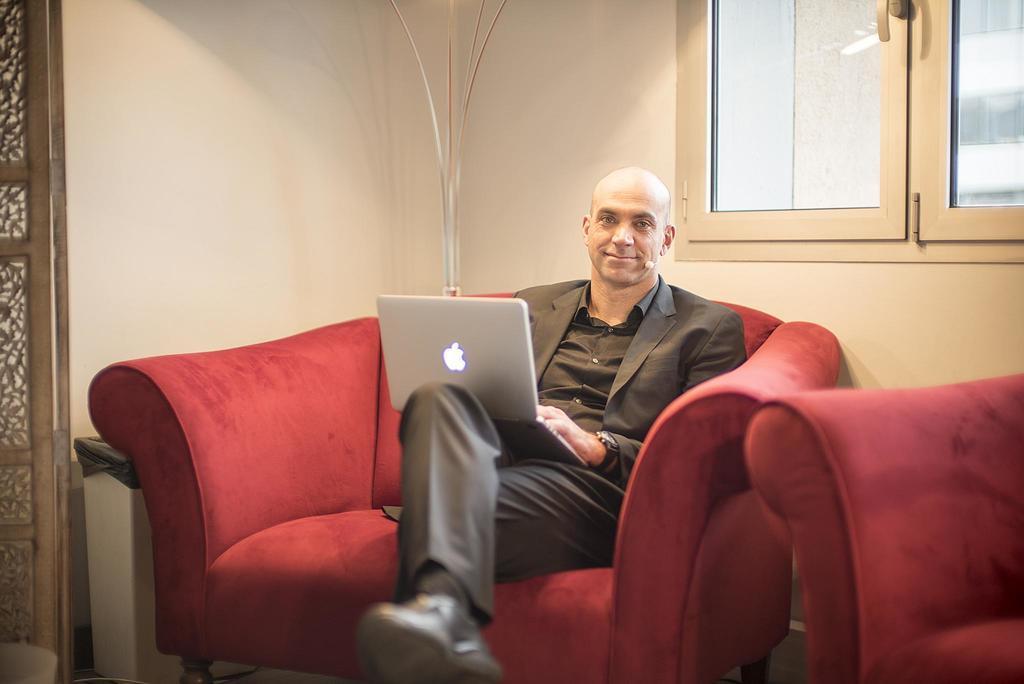Describe this image in one or two sentences. As we can see in the image there is a white color wall, windows, sofa and a man sitting on sofa and holding laptop in his hands. 